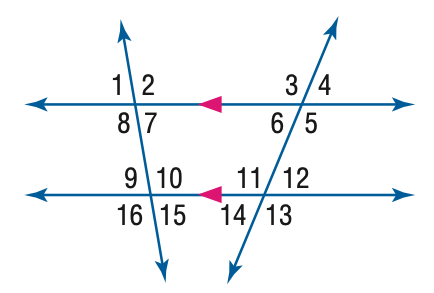What is the sum of the measures of angles 10 and 11? Angles 10 and 11 form a straight line, making them supplementary angles. As supplementary angles, their measures add up to 180 degrees. Without the specific measures for these angles, we can't determine their individual values, but their sum is indeed 180 degrees. 